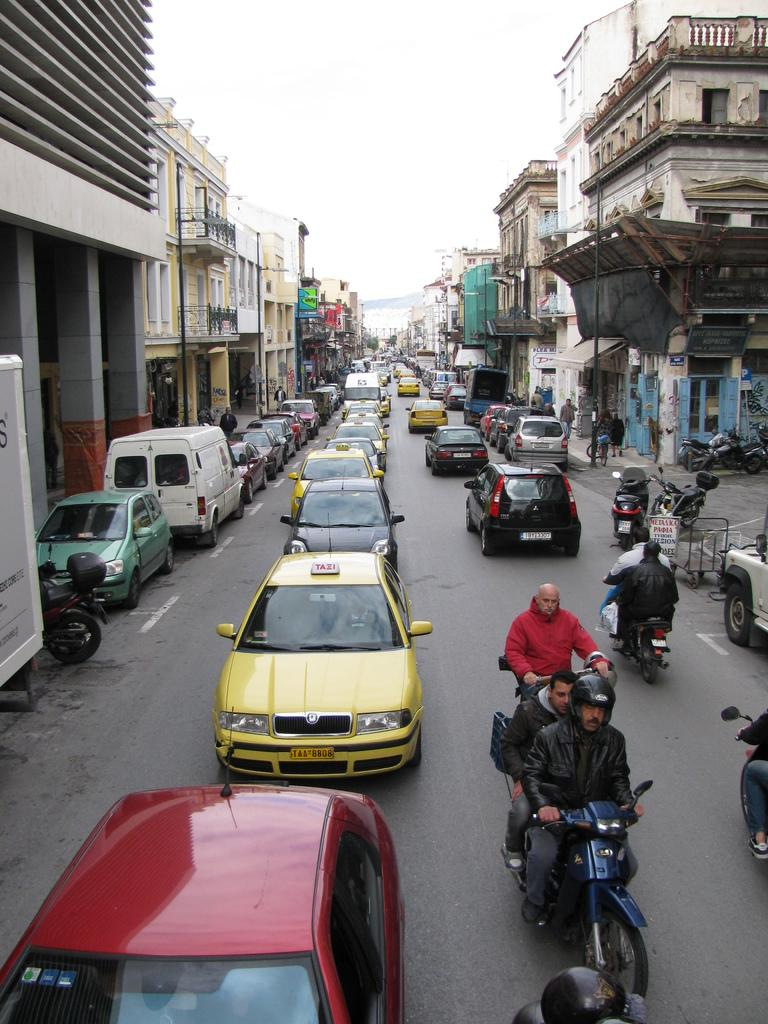What is the main subject of the image? The main subject of the image is vehicles. How are the vehicles arranged in the image? The vehicles are in lines on a road. What can be seen on both sides of the road in the image? There are buildings on both sides of the road. What is visible in the background of the image? The sky is visible in the background of the image. How many horses are galloping through the destruction in the image? There are no horses or destruction present in the image; it features vehicles on a road with buildings on both sides. 